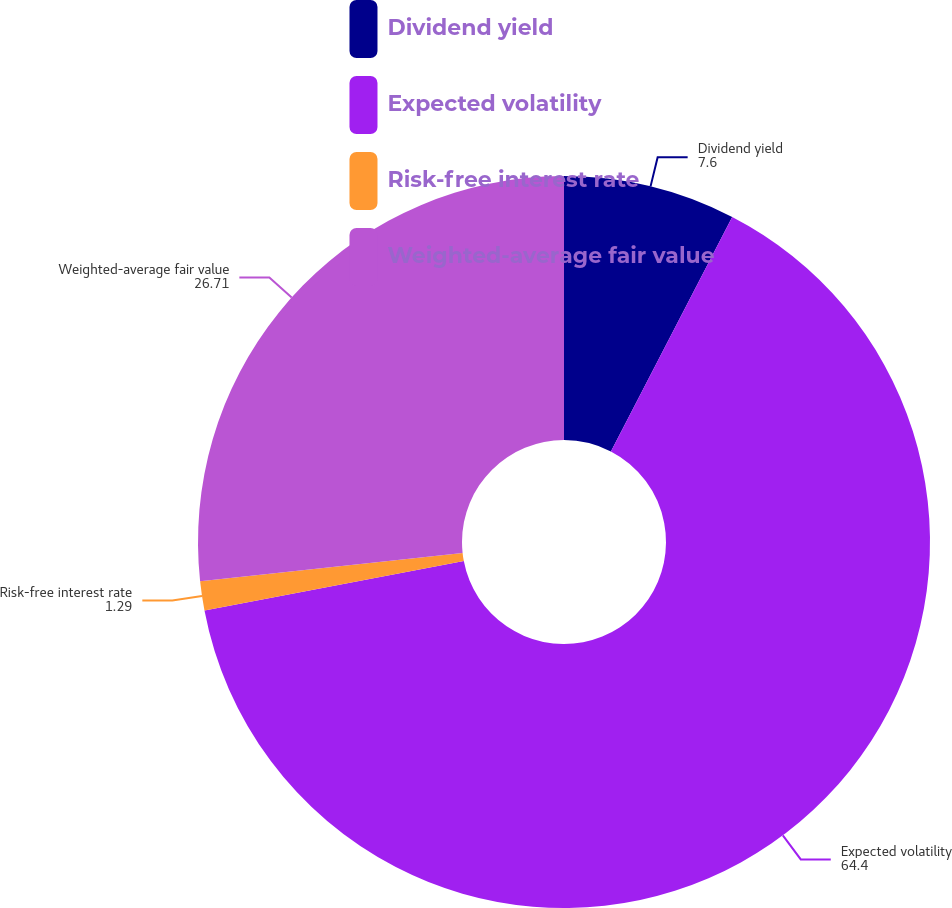Convert chart. <chart><loc_0><loc_0><loc_500><loc_500><pie_chart><fcel>Dividend yield<fcel>Expected volatility<fcel>Risk-free interest rate<fcel>Weighted-average fair value<nl><fcel>7.6%<fcel>64.4%<fcel>1.29%<fcel>26.71%<nl></chart> 